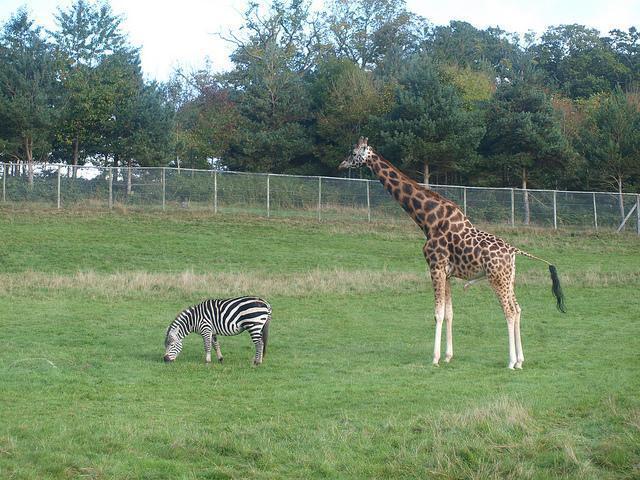How many zebra are there?
Give a very brief answer. 1. How many people are to the left of the motorcycles in this image?
Give a very brief answer. 0. 